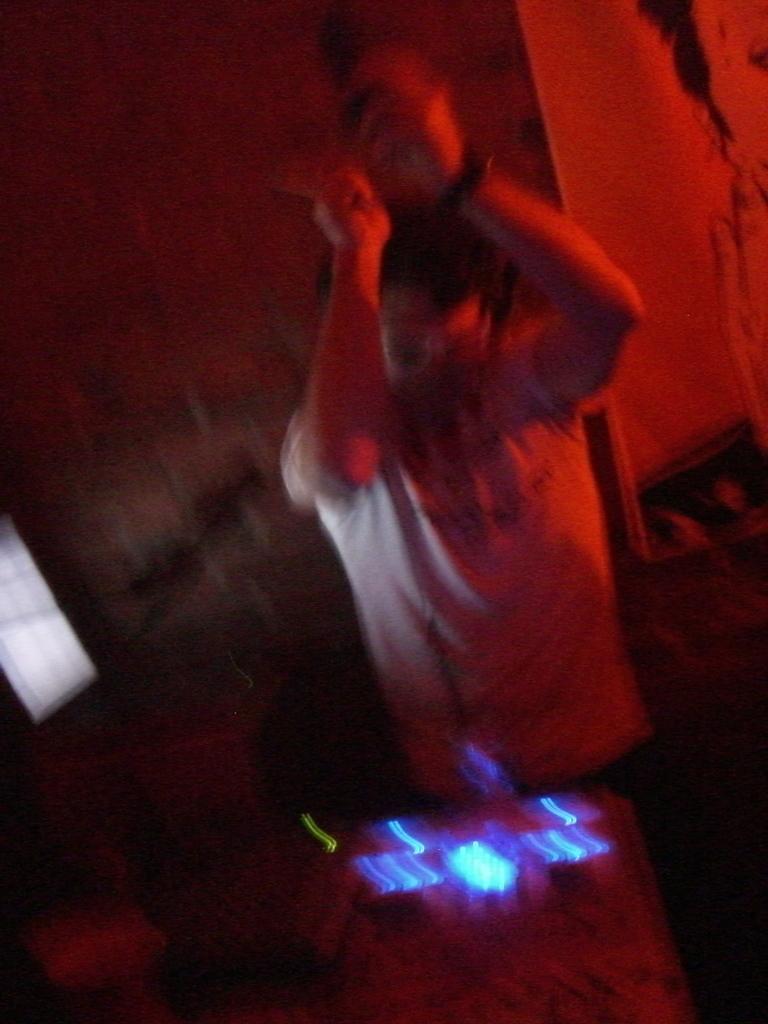Can you describe this image briefly? In this picture I can see a person in front and I can see a blue color thing on the bottom of this picture. In the background I can see the wall and on the left side of this picture I can see a white color thing and I see that this image is blurry. I can also see that this image is of red color. 